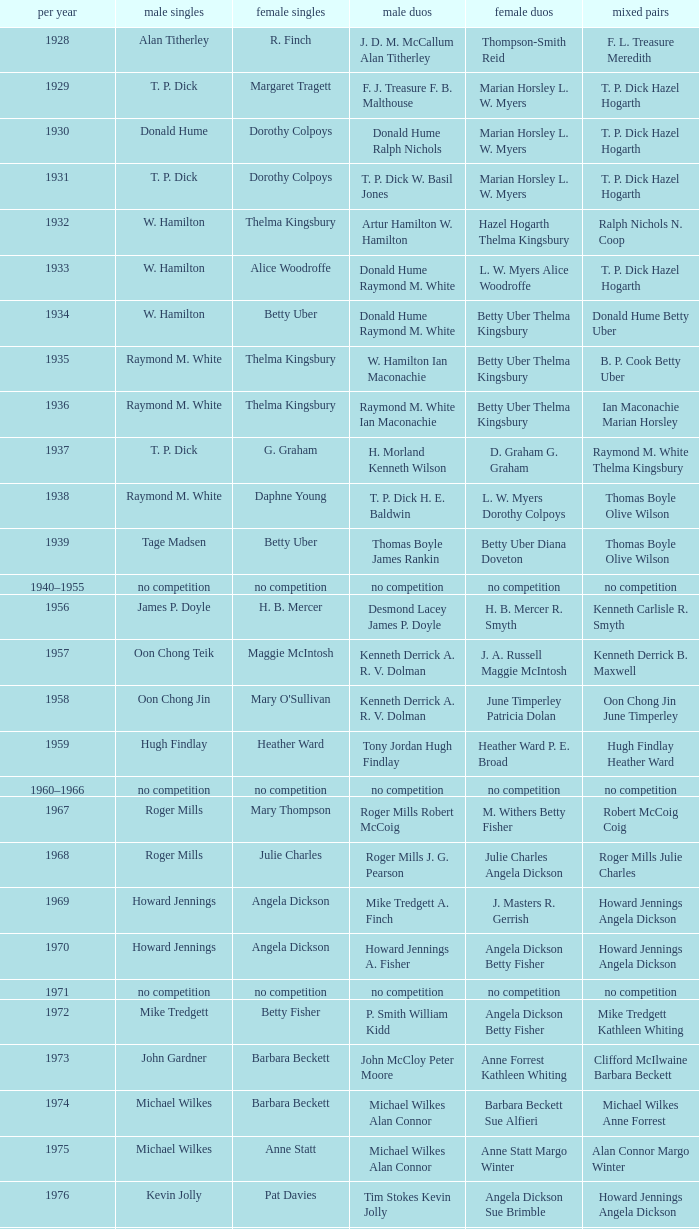Who won the Women's doubles in the year that Jesper Knudsen Nettie Nielsen won the Mixed doubles? Karen Beckman Sara Halsall. 